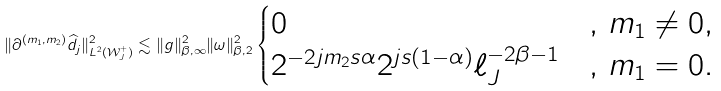Convert formula to latex. <formula><loc_0><loc_0><loc_500><loc_500>\| \partial ^ { ( m _ { 1 } , m _ { 2 } ) } \widehat { d _ { j } } \| ^ { 2 } _ { L ^ { 2 } ( \mathcal { W } ^ { + } _ { J } ) } \lesssim \| g \| ^ { 2 } _ { \beta , \infty } \| \omega \| ^ { 2 } _ { \beta , 2 } \begin{cases} 0 \quad & , \, m _ { 1 } \neq 0 , \\ 2 ^ { - 2 j m _ { 2 } s \alpha } 2 ^ { j s ( 1 - \alpha ) } \ell _ { J } ^ { - 2 \beta - 1 } & , \, m _ { 1 } = 0 . \end{cases}</formula> 